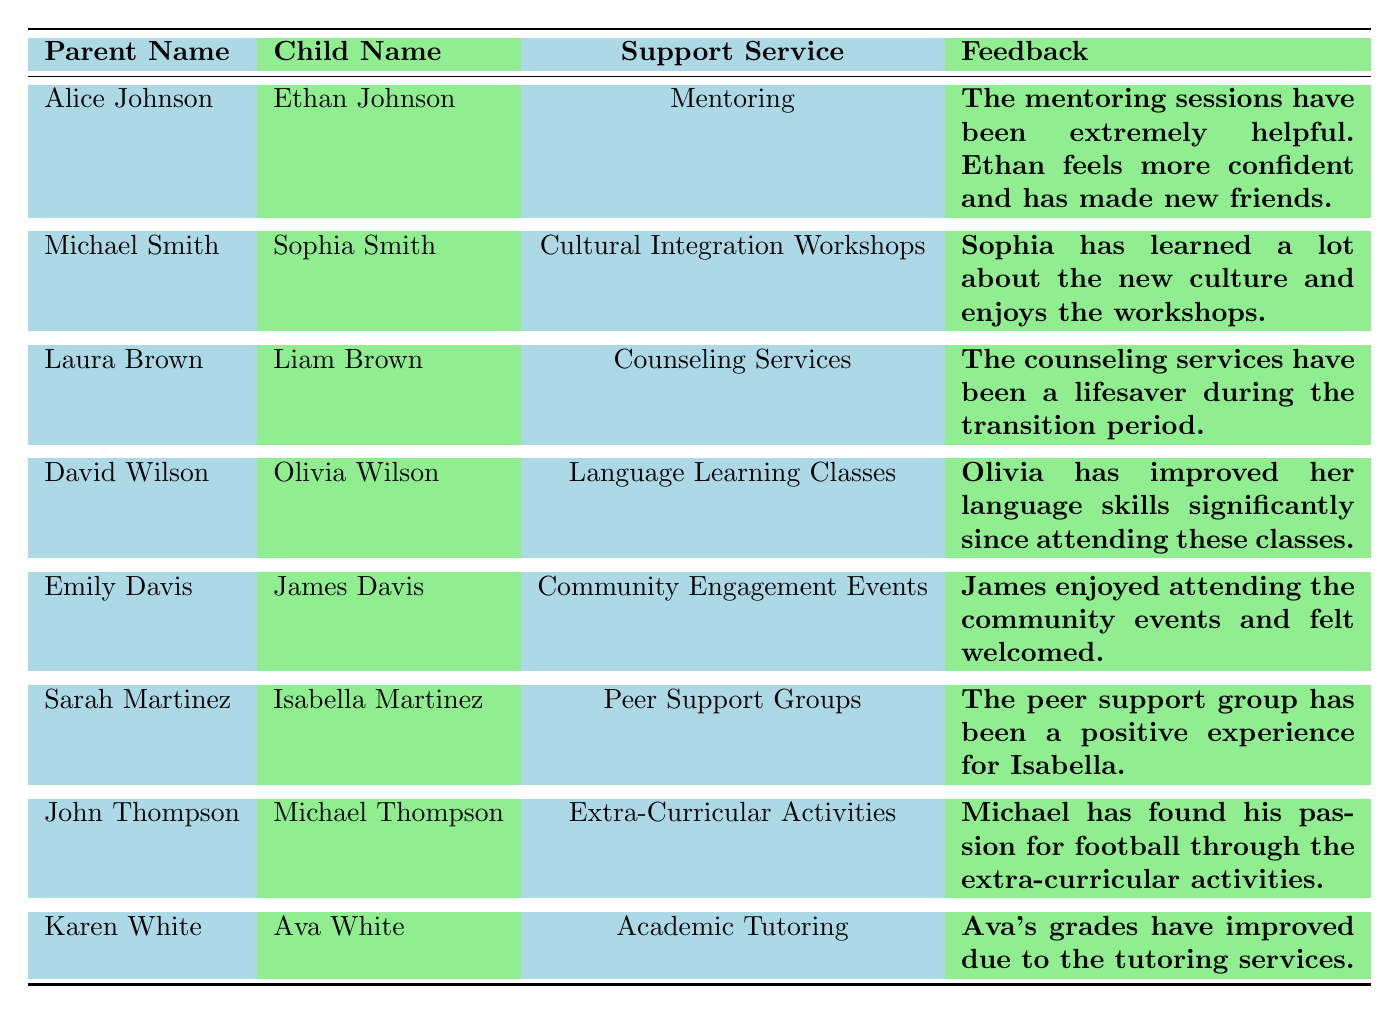What feedback did Alice Johnson provide about the mentoring service? Alice Johnson indicated that the mentoring sessions have been extremely helpful for her child, Ethan, and that he feels more confident and has made new friends.
Answer: The mentoring sessions have been extremely helpful What is the highest satisfaction rating among the support services? Review each satisfaction rating in the table: 4.8 (Mentoring), 4.5 (Cultural Integration Workshops), 4.9 (Counseling Services), 4.7 (Language Learning Classes), 4.6 (Community Engagement Events), 4.8 (Peer Support Groups), 4.4 (Extra-Curricular Activities), 4.9 (Academic Tutoring). The highest is 4.9 which appears for Counseling Services and Academic Tutoring.
Answer: 4.9 Which parent provided feedback for the Cultural Integration Workshops? The table lists Michael Smith as the parent who provided feedback for the Cultural Integration Workshops concerning his child, Sophia Smith.
Answer: Michael Smith True or False: Emily Davis indicated that James improved his language skills due to the support services. The feedback provided by Emily Davis relates to community events, not language skills, which were mentioned in the feedback for David Wilson's child, Olivia. Therefore, the statement is false.
Answer: False What is the average satisfaction rating for all support services listed? To find the average, sum the ratings: 4.8 + 4.5 + 4.9 + 4.7 + 4.6 + 4.8 + 4.4 + 4.9 = 36.6. There are 8 ratings, so the average is 36.6 / 8 = 4.575.
Answer: 4.575 How many feedback entries mention positive experiences regarding friendships or social connections? The feedback from Alice Johnson (Mentoring), Emily Davis (Community Engagement Events), and Sarah Martinez (Peer Support Groups) highlight positive experiences regarding friendships and social connections. This totals to three entries.
Answer: 3 Which support service received feedback indicating a need for more resources? John Thompson mentioned that the extra-curricular activities could use more resources.
Answer: Extra-Curricular Activities What feedback did Laura Brown give regarding the counseling services? Laura Brown described the counseling services as a lifesaver during the transition period, emphasizing their significance and the patient nature of the counselor.
Answer: The counseling services have been a lifesaver during the transition period Which child is associated with the highest rated satisfaction feedback? Review the satisfaction ratings: Ava White (4.9 for Academic Tutoring) and Liam Brown (4.9 for Counseling Services) are associated with the highest ratings of 4.9. Both children are connected to the highest rated feedback.
Answer: Ava White and Liam Brown 